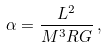<formula> <loc_0><loc_0><loc_500><loc_500>\alpha = \frac { L ^ { 2 } } { M ^ { 3 } R G } \, ,</formula> 